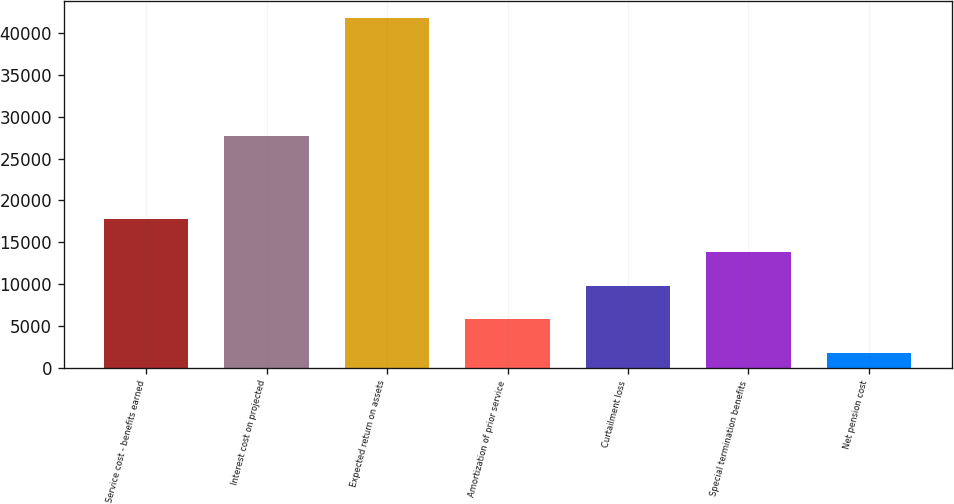<chart> <loc_0><loc_0><loc_500><loc_500><bar_chart><fcel>Service cost - benefits earned<fcel>Interest cost on projected<fcel>Expected return on assets<fcel>Amortization of prior service<fcel>Curtailment loss<fcel>Special termination benefits<fcel>Net pension cost<nl><fcel>17783.4<fcel>27708<fcel>41784<fcel>5783.1<fcel>9783.2<fcel>13783.3<fcel>1783<nl></chart> 